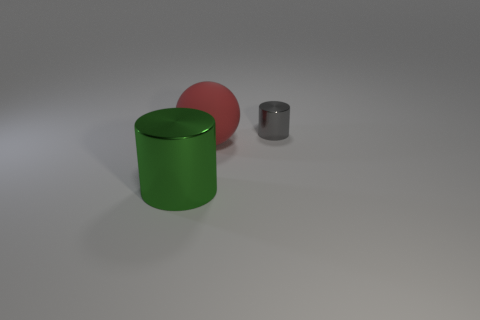What materials do the objects in the image look like they're made of? The objects in the image have a smooth and matte finish, which might suggest they are made of a plastic or metal with a matte surface treatment. 